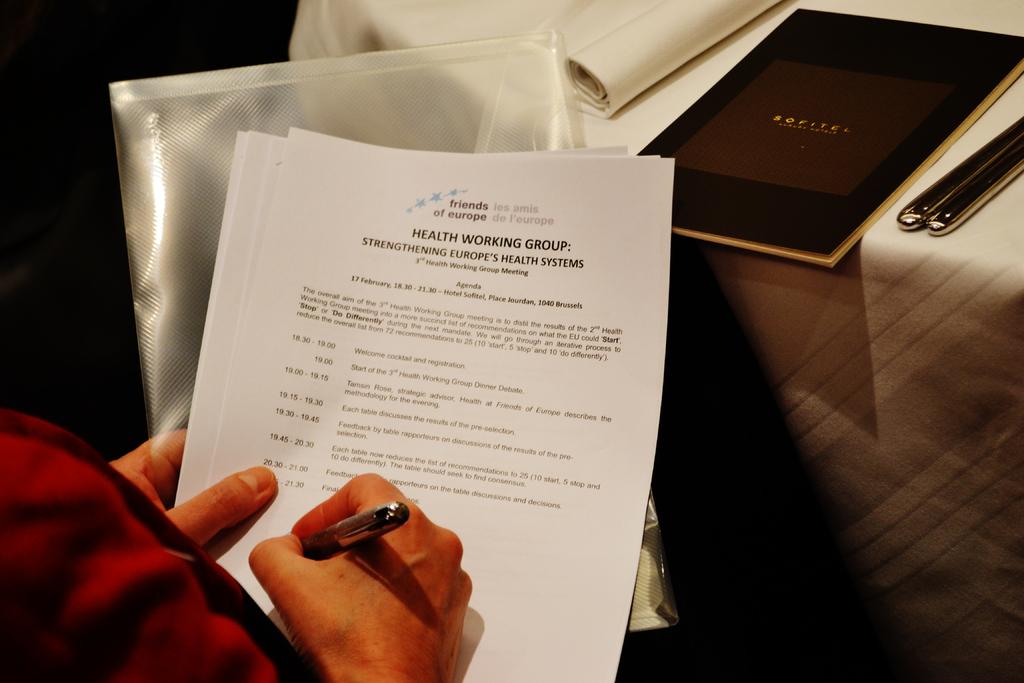Which continent is getting its health system strengthened?
Your answer should be very brief. Europe. In what month was the conference held?
Make the answer very short. February. 